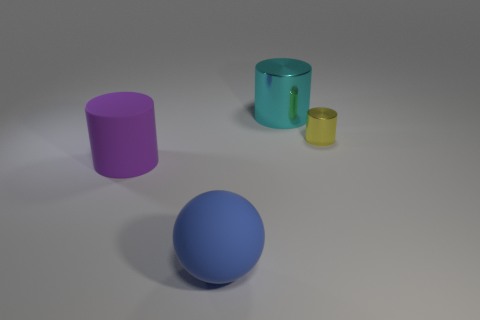How many objects are tiny cylinders or tiny gray shiny spheres?
Your answer should be compact. 1. What number of other things are the same color as the big matte cylinder?
Make the answer very short. 0. What is the shape of the blue object that is the same size as the cyan cylinder?
Offer a very short reply. Sphere. There is a big cylinder in front of the small metallic object; what color is it?
Your answer should be compact. Purple. What number of objects are either objects in front of the rubber cylinder or objects that are to the left of the small metal thing?
Your response must be concise. 3. Is the size of the blue sphere the same as the cyan cylinder?
Keep it short and to the point. Yes. How many cylinders are purple matte things or small things?
Your answer should be compact. 2. How many objects are both in front of the cyan thing and to the left of the tiny thing?
Your answer should be very brief. 2. There is a purple object; is it the same size as the ball in front of the yellow metal cylinder?
Offer a terse response. Yes. There is a large object on the right side of the thing that is in front of the purple rubber cylinder; are there any yellow things that are to the left of it?
Your response must be concise. No. 